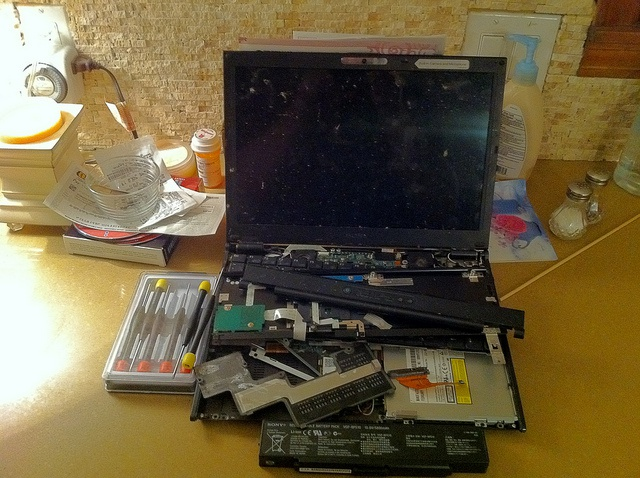Describe the objects in this image and their specific colors. I can see laptop in khaki, black, gray, and olive tones, bottle in khaki, gray, and olive tones, bowl in khaki, gray, and darkgray tones, book in khaki, olive, black, and gray tones, and bottle in khaki and olive tones in this image. 